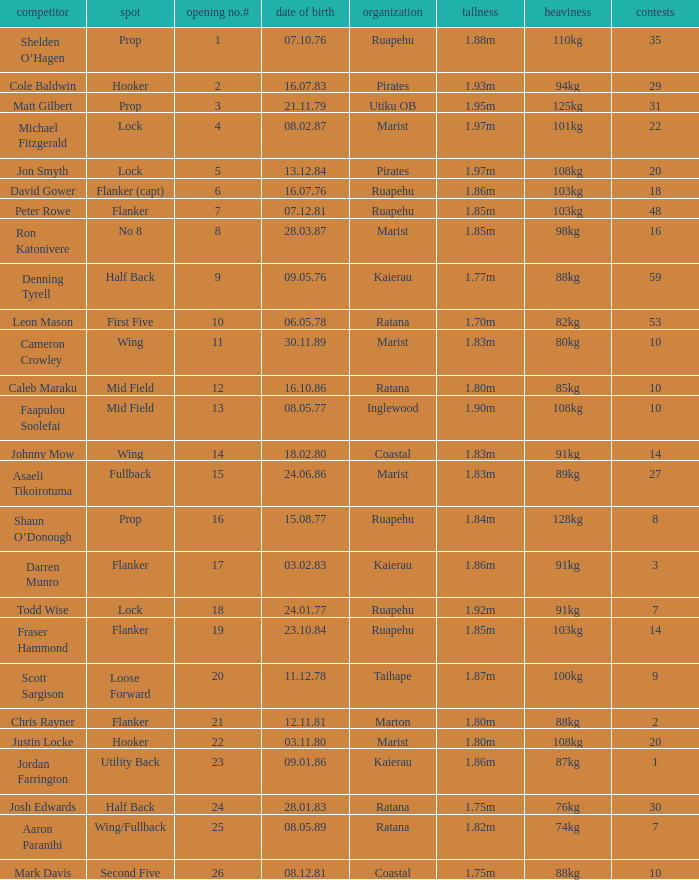What is the date of birth for the player in the Inglewood club? 80577.0. 